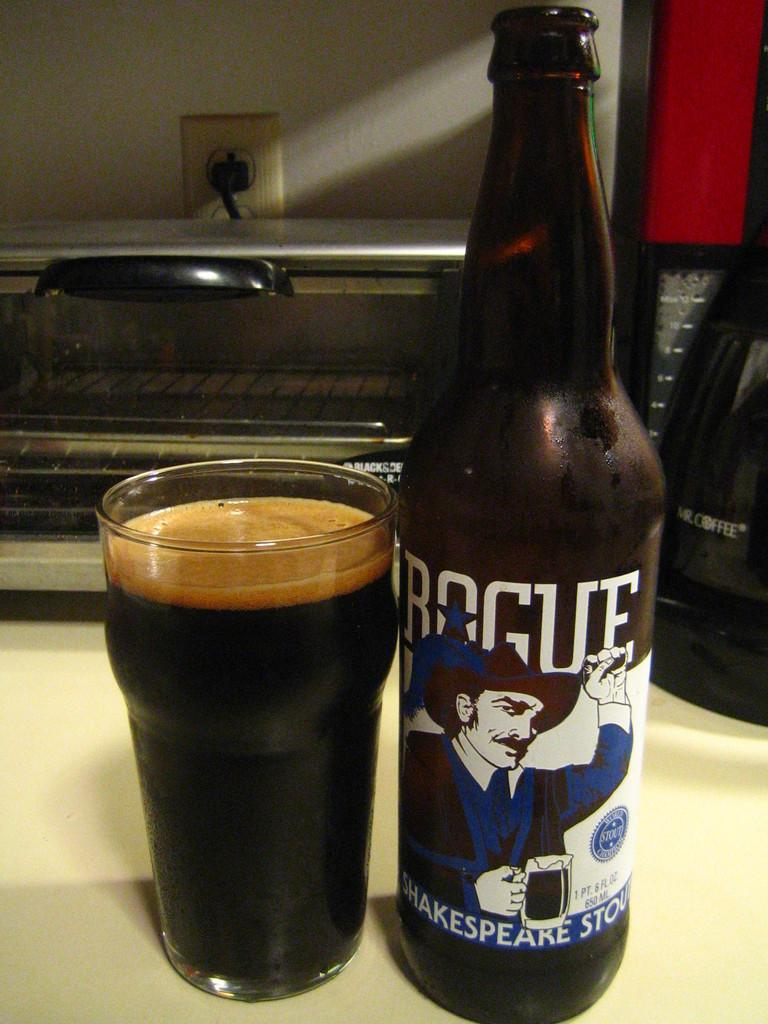Provide a one-sentence caption for the provided image. A bottle of Rogue Shakespeare Stout sits next to a full glass. 